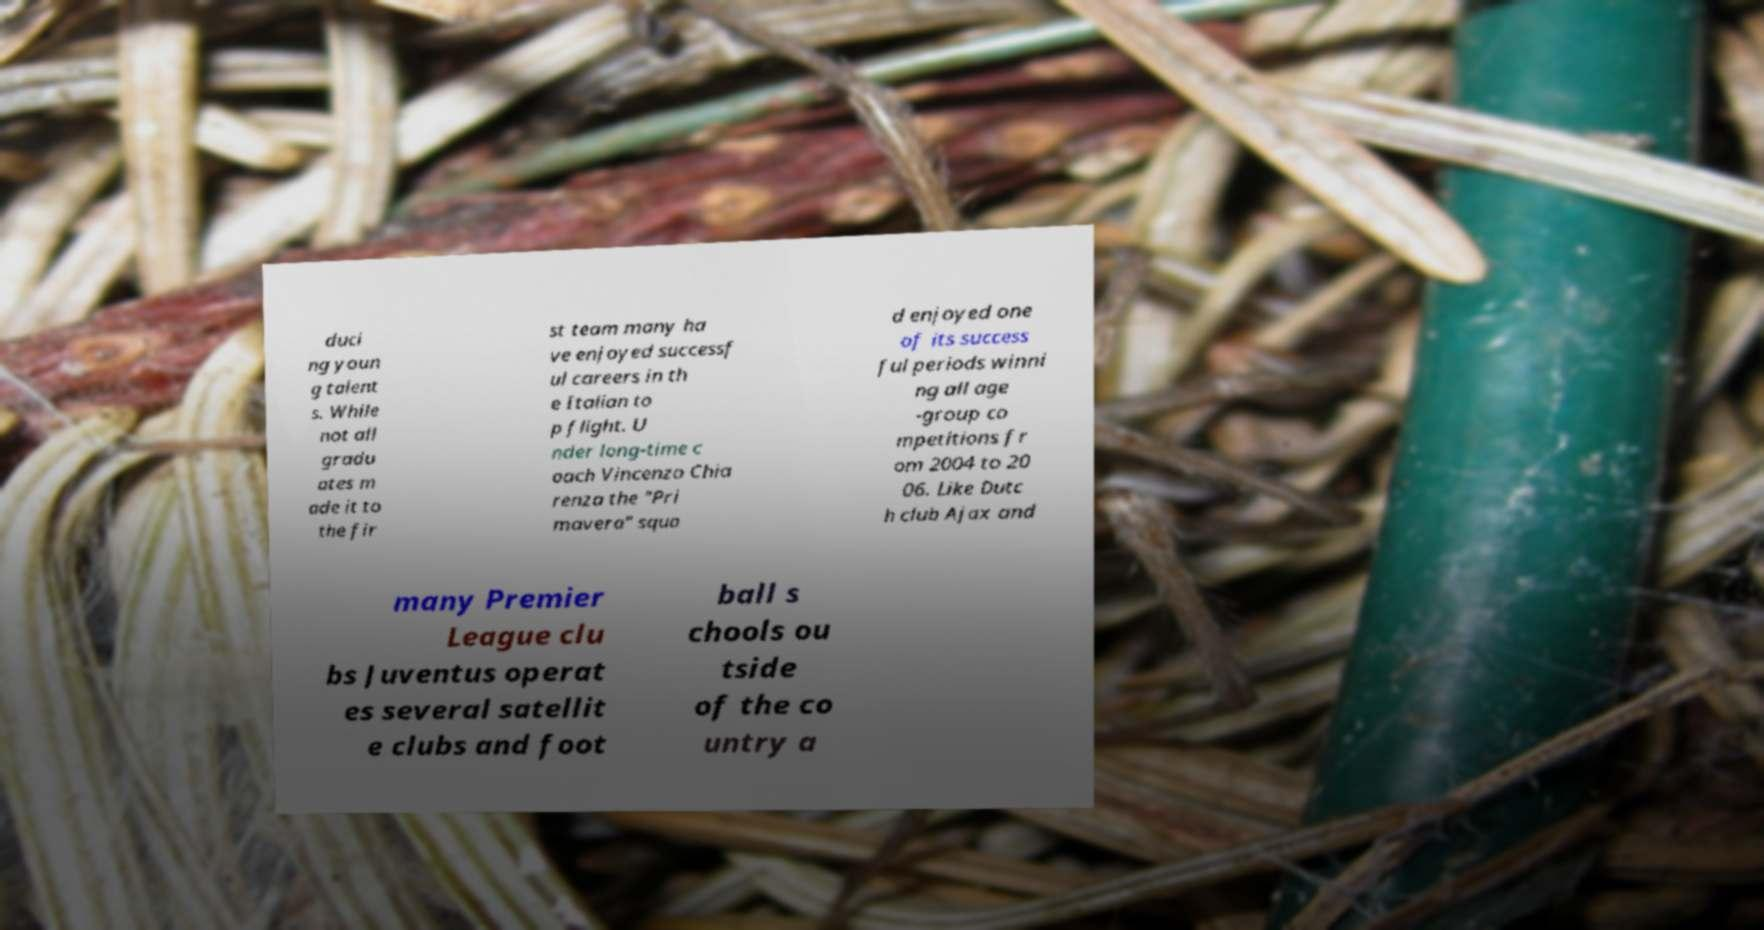I need the written content from this picture converted into text. Can you do that? duci ng youn g talent s. While not all gradu ates m ade it to the fir st team many ha ve enjoyed successf ul careers in th e Italian to p flight. U nder long-time c oach Vincenzo Chia renza the "Pri mavera" squa d enjoyed one of its success ful periods winni ng all age -group co mpetitions fr om 2004 to 20 06. Like Dutc h club Ajax and many Premier League clu bs Juventus operat es several satellit e clubs and foot ball s chools ou tside of the co untry a 